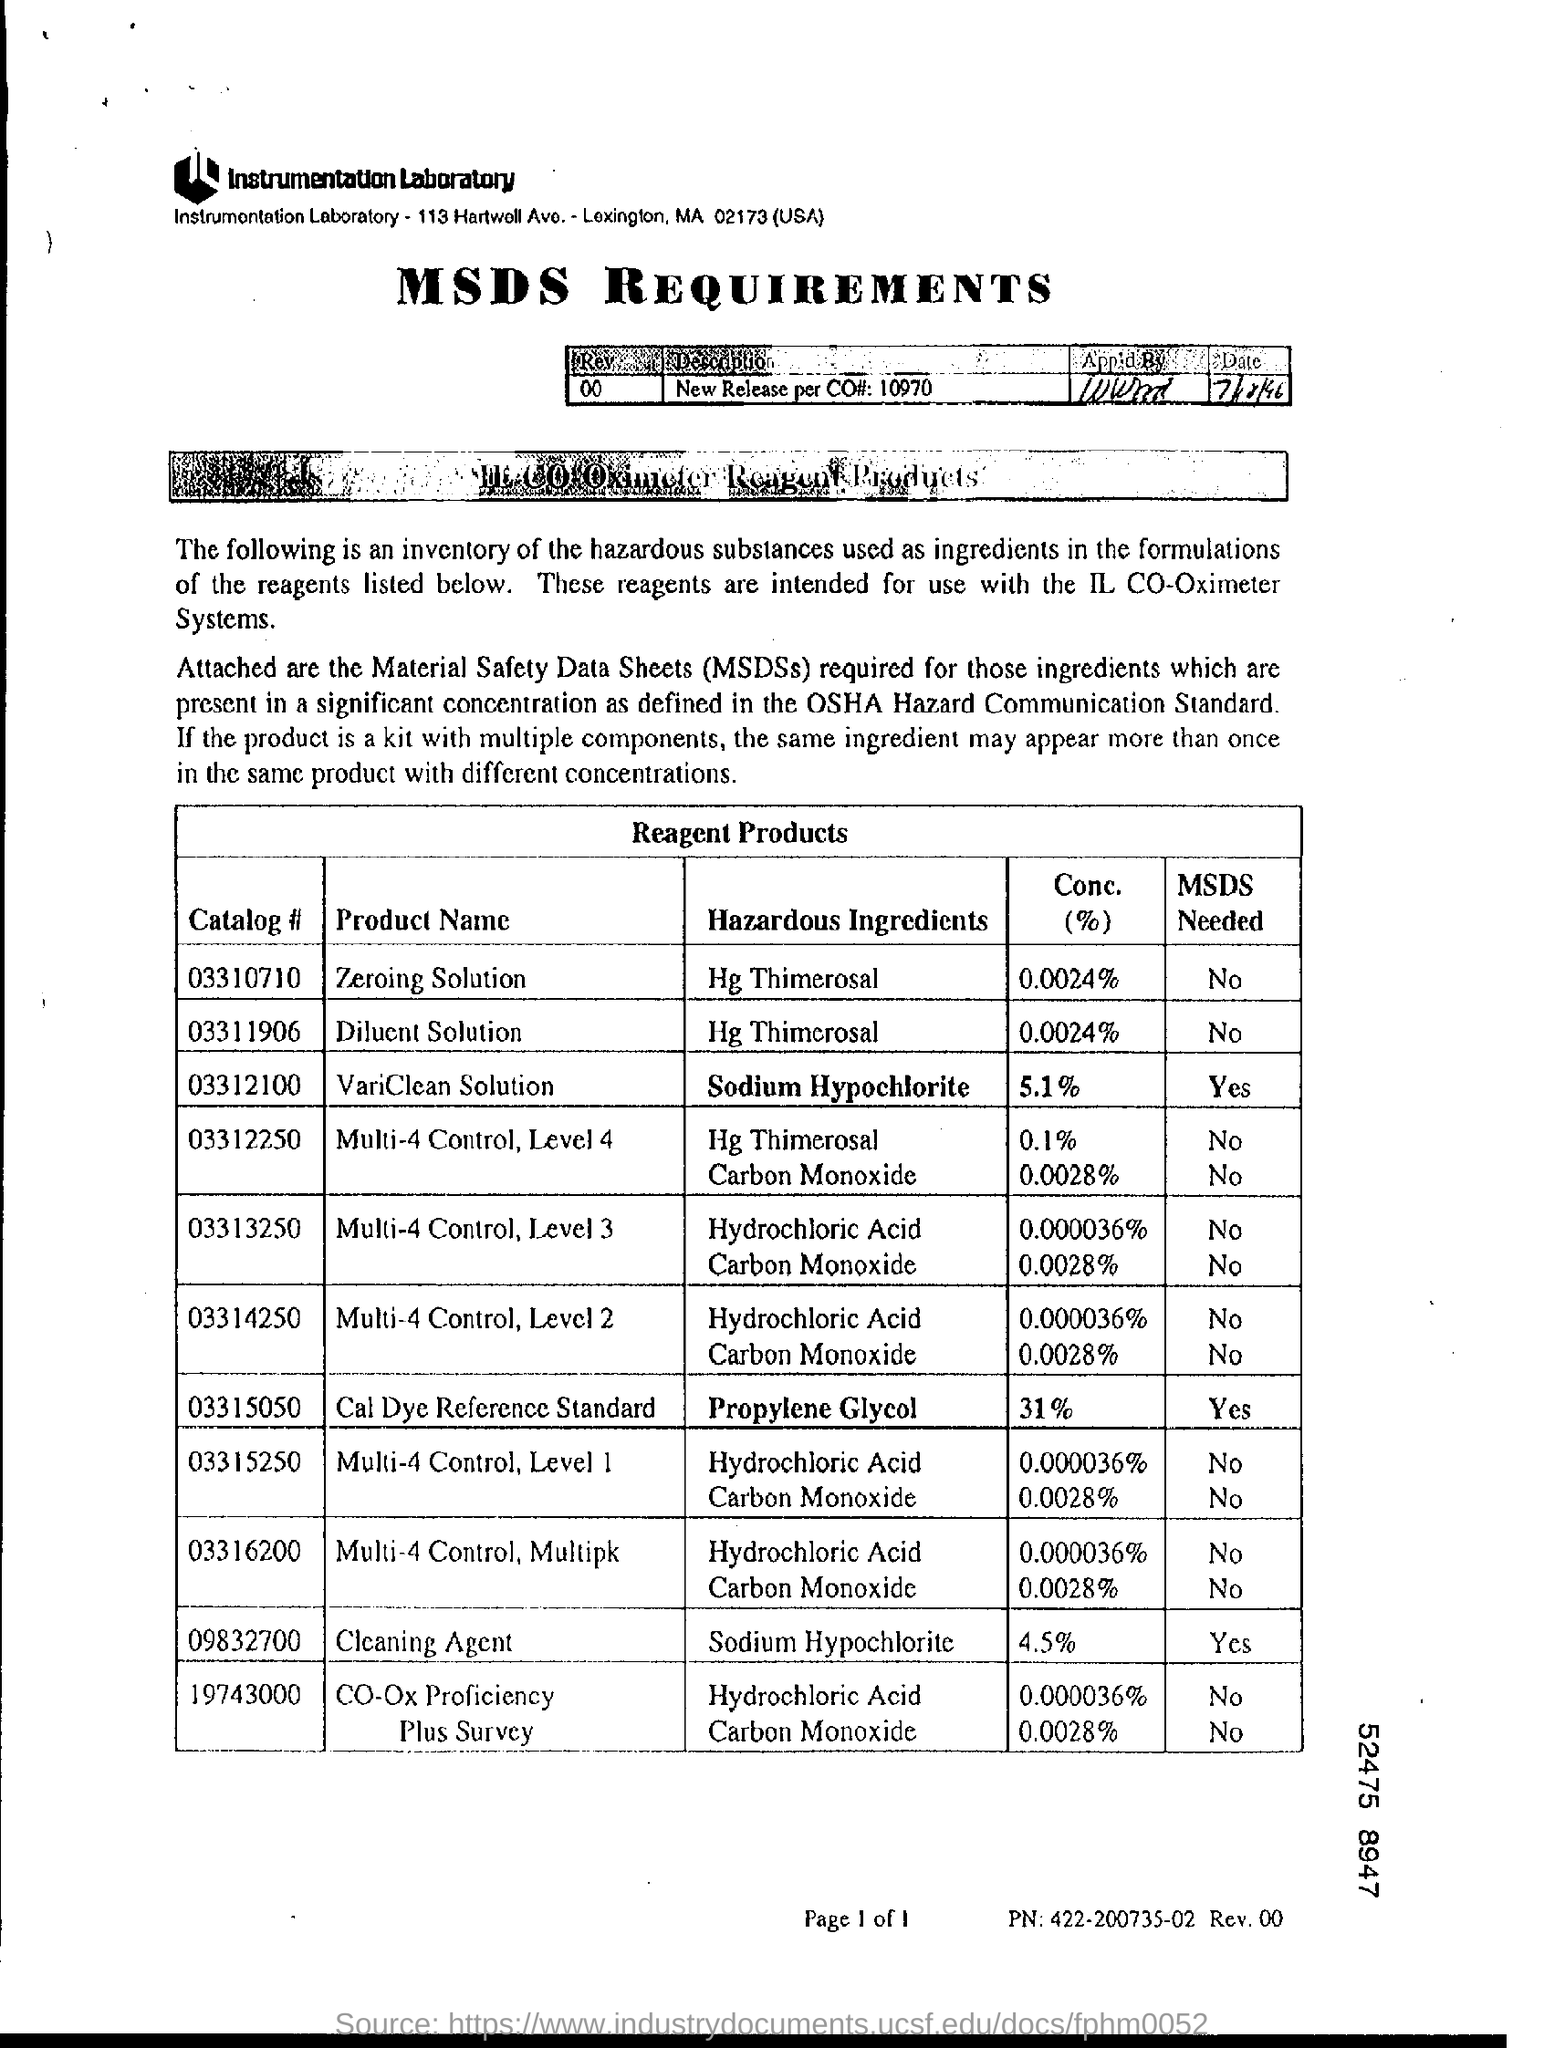What is the Catalog # for Zeroing Solution?
Offer a terse response. 03310710. What is the Catalog # for Diluent solution?
Your answer should be very brief. 03311906. What is the Catalog # for VariClean Solution
Ensure brevity in your answer.  03312100. What is the Catalog # for Cleaning Agent?
Provide a short and direct response. 09832700. What are the Conc. (%) for Zeroing Solution?
Ensure brevity in your answer.  0.0024%. What are the Conc. (%) for VariClean Solution?
Ensure brevity in your answer.  5.1%. What are the Conc. (%) for Cleaning Agent?
Give a very brief answer. 4.5%. 